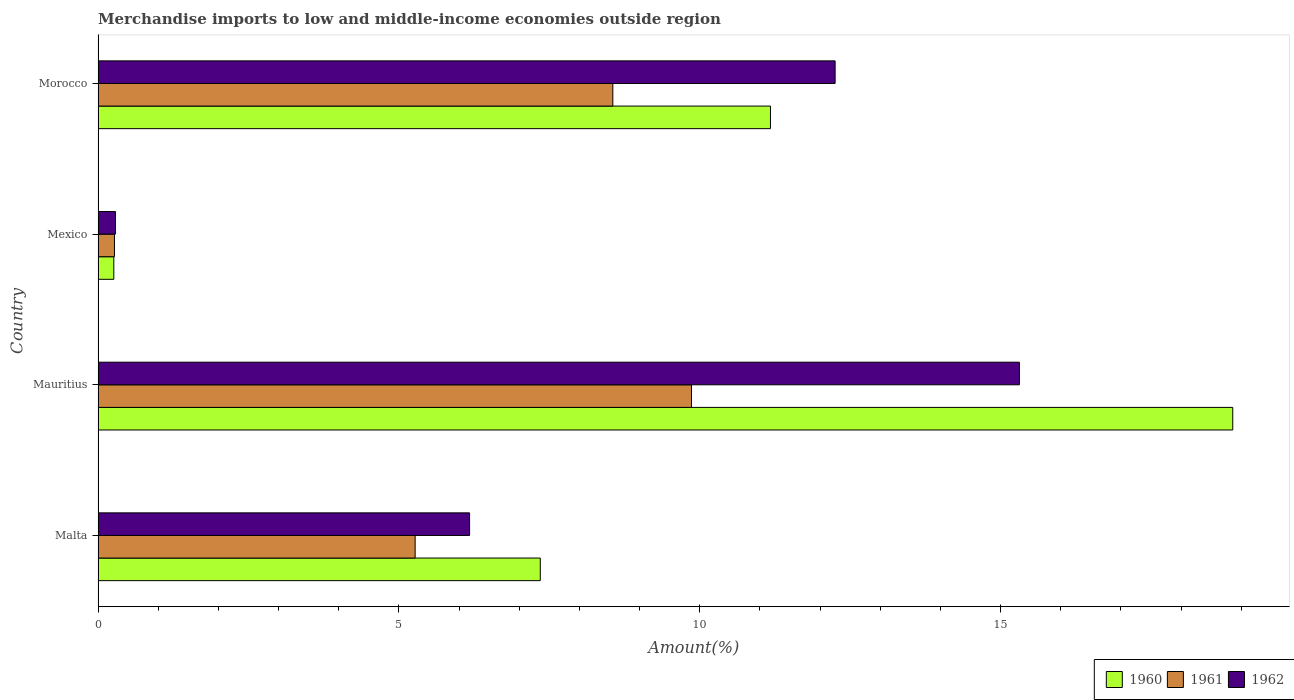How many different coloured bars are there?
Ensure brevity in your answer.  3. How many groups of bars are there?
Provide a short and direct response. 4. Are the number of bars per tick equal to the number of legend labels?
Your answer should be compact. Yes. How many bars are there on the 2nd tick from the bottom?
Your answer should be very brief. 3. In how many cases, is the number of bars for a given country not equal to the number of legend labels?
Your response must be concise. 0. What is the percentage of amount earned from merchandise imports in 1960 in Malta?
Your response must be concise. 7.35. Across all countries, what is the maximum percentage of amount earned from merchandise imports in 1960?
Provide a succinct answer. 18.86. Across all countries, what is the minimum percentage of amount earned from merchandise imports in 1962?
Give a very brief answer. 0.29. In which country was the percentage of amount earned from merchandise imports in 1960 maximum?
Ensure brevity in your answer.  Mauritius. In which country was the percentage of amount earned from merchandise imports in 1962 minimum?
Offer a very short reply. Mexico. What is the total percentage of amount earned from merchandise imports in 1960 in the graph?
Your response must be concise. 37.65. What is the difference between the percentage of amount earned from merchandise imports in 1961 in Mexico and that in Morocco?
Offer a terse response. -8.28. What is the difference between the percentage of amount earned from merchandise imports in 1961 in Morocco and the percentage of amount earned from merchandise imports in 1960 in Mexico?
Provide a short and direct response. 8.29. What is the average percentage of amount earned from merchandise imports in 1961 per country?
Provide a short and direct response. 5.99. What is the difference between the percentage of amount earned from merchandise imports in 1960 and percentage of amount earned from merchandise imports in 1962 in Malta?
Your answer should be compact. 1.17. What is the ratio of the percentage of amount earned from merchandise imports in 1960 in Mauritius to that in Morocco?
Provide a short and direct response. 1.69. Is the percentage of amount earned from merchandise imports in 1962 in Malta less than that in Mexico?
Offer a very short reply. No. What is the difference between the highest and the second highest percentage of amount earned from merchandise imports in 1961?
Keep it short and to the point. 1.31. What is the difference between the highest and the lowest percentage of amount earned from merchandise imports in 1962?
Offer a very short reply. 15.02. What does the 1st bar from the top in Mauritius represents?
Provide a short and direct response. 1962. How many countries are there in the graph?
Give a very brief answer. 4. What is the difference between two consecutive major ticks on the X-axis?
Ensure brevity in your answer.  5. Are the values on the major ticks of X-axis written in scientific E-notation?
Ensure brevity in your answer.  No. Does the graph contain grids?
Provide a short and direct response. No. Where does the legend appear in the graph?
Provide a short and direct response. Bottom right. How many legend labels are there?
Offer a terse response. 3. What is the title of the graph?
Give a very brief answer. Merchandise imports to low and middle-income economies outside region. What is the label or title of the X-axis?
Offer a terse response. Amount(%). What is the Amount(%) in 1960 in Malta?
Give a very brief answer. 7.35. What is the Amount(%) of 1961 in Malta?
Give a very brief answer. 5.27. What is the Amount(%) in 1962 in Malta?
Ensure brevity in your answer.  6.18. What is the Amount(%) of 1960 in Mauritius?
Your response must be concise. 18.86. What is the Amount(%) of 1961 in Mauritius?
Ensure brevity in your answer.  9.86. What is the Amount(%) of 1962 in Mauritius?
Make the answer very short. 15.31. What is the Amount(%) in 1960 in Mexico?
Keep it short and to the point. 0.26. What is the Amount(%) of 1961 in Mexico?
Ensure brevity in your answer.  0.27. What is the Amount(%) of 1962 in Mexico?
Ensure brevity in your answer.  0.29. What is the Amount(%) of 1960 in Morocco?
Provide a succinct answer. 11.18. What is the Amount(%) in 1961 in Morocco?
Give a very brief answer. 8.56. What is the Amount(%) of 1962 in Morocco?
Your answer should be very brief. 12.25. Across all countries, what is the maximum Amount(%) of 1960?
Keep it short and to the point. 18.86. Across all countries, what is the maximum Amount(%) in 1961?
Offer a very short reply. 9.86. Across all countries, what is the maximum Amount(%) of 1962?
Provide a succinct answer. 15.31. Across all countries, what is the minimum Amount(%) in 1960?
Give a very brief answer. 0.26. Across all countries, what is the minimum Amount(%) in 1961?
Make the answer very short. 0.27. Across all countries, what is the minimum Amount(%) of 1962?
Your answer should be compact. 0.29. What is the total Amount(%) of 1960 in the graph?
Offer a terse response. 37.65. What is the total Amount(%) in 1961 in the graph?
Ensure brevity in your answer.  23.96. What is the total Amount(%) in 1962 in the graph?
Your answer should be very brief. 34.03. What is the difference between the Amount(%) in 1960 in Malta and that in Mauritius?
Your answer should be very brief. -11.51. What is the difference between the Amount(%) of 1961 in Malta and that in Mauritius?
Offer a terse response. -4.59. What is the difference between the Amount(%) in 1962 in Malta and that in Mauritius?
Keep it short and to the point. -9.14. What is the difference between the Amount(%) of 1960 in Malta and that in Mexico?
Provide a short and direct response. 7.09. What is the difference between the Amount(%) of 1961 in Malta and that in Mexico?
Ensure brevity in your answer.  5. What is the difference between the Amount(%) of 1962 in Malta and that in Mexico?
Ensure brevity in your answer.  5.89. What is the difference between the Amount(%) of 1960 in Malta and that in Morocco?
Your response must be concise. -3.83. What is the difference between the Amount(%) in 1961 in Malta and that in Morocco?
Your answer should be compact. -3.29. What is the difference between the Amount(%) in 1962 in Malta and that in Morocco?
Provide a succinct answer. -6.08. What is the difference between the Amount(%) in 1960 in Mauritius and that in Mexico?
Provide a succinct answer. 18.6. What is the difference between the Amount(%) of 1961 in Mauritius and that in Mexico?
Keep it short and to the point. 9.59. What is the difference between the Amount(%) in 1962 in Mauritius and that in Mexico?
Your answer should be very brief. 15.02. What is the difference between the Amount(%) of 1960 in Mauritius and that in Morocco?
Your answer should be compact. 7.68. What is the difference between the Amount(%) in 1961 in Mauritius and that in Morocco?
Ensure brevity in your answer.  1.31. What is the difference between the Amount(%) in 1962 in Mauritius and that in Morocco?
Make the answer very short. 3.06. What is the difference between the Amount(%) of 1960 in Mexico and that in Morocco?
Make the answer very short. -10.91. What is the difference between the Amount(%) in 1961 in Mexico and that in Morocco?
Offer a very short reply. -8.28. What is the difference between the Amount(%) in 1962 in Mexico and that in Morocco?
Provide a succinct answer. -11.96. What is the difference between the Amount(%) in 1960 in Malta and the Amount(%) in 1961 in Mauritius?
Provide a short and direct response. -2.51. What is the difference between the Amount(%) of 1960 in Malta and the Amount(%) of 1962 in Mauritius?
Offer a terse response. -7.96. What is the difference between the Amount(%) of 1961 in Malta and the Amount(%) of 1962 in Mauritius?
Your answer should be compact. -10.04. What is the difference between the Amount(%) of 1960 in Malta and the Amount(%) of 1961 in Mexico?
Keep it short and to the point. 7.08. What is the difference between the Amount(%) in 1960 in Malta and the Amount(%) in 1962 in Mexico?
Keep it short and to the point. 7.06. What is the difference between the Amount(%) of 1961 in Malta and the Amount(%) of 1962 in Mexico?
Your answer should be very brief. 4.98. What is the difference between the Amount(%) of 1960 in Malta and the Amount(%) of 1961 in Morocco?
Your response must be concise. -1.21. What is the difference between the Amount(%) of 1960 in Malta and the Amount(%) of 1962 in Morocco?
Your response must be concise. -4.9. What is the difference between the Amount(%) in 1961 in Malta and the Amount(%) in 1962 in Morocco?
Keep it short and to the point. -6.98. What is the difference between the Amount(%) of 1960 in Mauritius and the Amount(%) of 1961 in Mexico?
Keep it short and to the point. 18.59. What is the difference between the Amount(%) in 1960 in Mauritius and the Amount(%) in 1962 in Mexico?
Your answer should be compact. 18.57. What is the difference between the Amount(%) of 1961 in Mauritius and the Amount(%) of 1962 in Mexico?
Ensure brevity in your answer.  9.57. What is the difference between the Amount(%) of 1960 in Mauritius and the Amount(%) of 1961 in Morocco?
Provide a succinct answer. 10.3. What is the difference between the Amount(%) of 1960 in Mauritius and the Amount(%) of 1962 in Morocco?
Make the answer very short. 6.61. What is the difference between the Amount(%) of 1961 in Mauritius and the Amount(%) of 1962 in Morocco?
Give a very brief answer. -2.39. What is the difference between the Amount(%) of 1960 in Mexico and the Amount(%) of 1961 in Morocco?
Your response must be concise. -8.29. What is the difference between the Amount(%) of 1960 in Mexico and the Amount(%) of 1962 in Morocco?
Offer a very short reply. -11.99. What is the difference between the Amount(%) in 1961 in Mexico and the Amount(%) in 1962 in Morocco?
Provide a succinct answer. -11.98. What is the average Amount(%) of 1960 per country?
Your answer should be very brief. 9.41. What is the average Amount(%) in 1961 per country?
Your response must be concise. 5.99. What is the average Amount(%) of 1962 per country?
Offer a very short reply. 8.51. What is the difference between the Amount(%) in 1960 and Amount(%) in 1961 in Malta?
Offer a terse response. 2.08. What is the difference between the Amount(%) of 1960 and Amount(%) of 1962 in Malta?
Provide a short and direct response. 1.17. What is the difference between the Amount(%) in 1961 and Amount(%) in 1962 in Malta?
Offer a terse response. -0.9. What is the difference between the Amount(%) in 1960 and Amount(%) in 1961 in Mauritius?
Your answer should be compact. 9. What is the difference between the Amount(%) in 1960 and Amount(%) in 1962 in Mauritius?
Your response must be concise. 3.55. What is the difference between the Amount(%) of 1961 and Amount(%) of 1962 in Mauritius?
Keep it short and to the point. -5.45. What is the difference between the Amount(%) in 1960 and Amount(%) in 1961 in Mexico?
Provide a short and direct response. -0.01. What is the difference between the Amount(%) in 1960 and Amount(%) in 1962 in Mexico?
Your response must be concise. -0.03. What is the difference between the Amount(%) of 1961 and Amount(%) of 1962 in Mexico?
Offer a very short reply. -0.02. What is the difference between the Amount(%) in 1960 and Amount(%) in 1961 in Morocco?
Give a very brief answer. 2.62. What is the difference between the Amount(%) in 1960 and Amount(%) in 1962 in Morocco?
Make the answer very short. -1.07. What is the difference between the Amount(%) of 1961 and Amount(%) of 1962 in Morocco?
Your answer should be very brief. -3.69. What is the ratio of the Amount(%) in 1960 in Malta to that in Mauritius?
Ensure brevity in your answer.  0.39. What is the ratio of the Amount(%) in 1961 in Malta to that in Mauritius?
Make the answer very short. 0.53. What is the ratio of the Amount(%) in 1962 in Malta to that in Mauritius?
Offer a terse response. 0.4. What is the ratio of the Amount(%) in 1960 in Malta to that in Mexico?
Your answer should be compact. 28.05. What is the ratio of the Amount(%) in 1961 in Malta to that in Mexico?
Offer a very short reply. 19.32. What is the ratio of the Amount(%) in 1962 in Malta to that in Mexico?
Offer a very short reply. 21.31. What is the ratio of the Amount(%) of 1960 in Malta to that in Morocco?
Ensure brevity in your answer.  0.66. What is the ratio of the Amount(%) of 1961 in Malta to that in Morocco?
Your answer should be very brief. 0.62. What is the ratio of the Amount(%) in 1962 in Malta to that in Morocco?
Provide a succinct answer. 0.5. What is the ratio of the Amount(%) in 1960 in Mauritius to that in Mexico?
Ensure brevity in your answer.  71.98. What is the ratio of the Amount(%) of 1961 in Mauritius to that in Mexico?
Make the answer very short. 36.15. What is the ratio of the Amount(%) of 1962 in Mauritius to that in Mexico?
Offer a very short reply. 52.86. What is the ratio of the Amount(%) in 1960 in Mauritius to that in Morocco?
Offer a terse response. 1.69. What is the ratio of the Amount(%) in 1961 in Mauritius to that in Morocco?
Your response must be concise. 1.15. What is the ratio of the Amount(%) of 1962 in Mauritius to that in Morocco?
Provide a succinct answer. 1.25. What is the ratio of the Amount(%) in 1960 in Mexico to that in Morocco?
Make the answer very short. 0.02. What is the ratio of the Amount(%) of 1961 in Mexico to that in Morocco?
Your answer should be compact. 0.03. What is the ratio of the Amount(%) of 1962 in Mexico to that in Morocco?
Give a very brief answer. 0.02. What is the difference between the highest and the second highest Amount(%) of 1960?
Your response must be concise. 7.68. What is the difference between the highest and the second highest Amount(%) of 1961?
Offer a terse response. 1.31. What is the difference between the highest and the second highest Amount(%) in 1962?
Your answer should be compact. 3.06. What is the difference between the highest and the lowest Amount(%) in 1960?
Ensure brevity in your answer.  18.6. What is the difference between the highest and the lowest Amount(%) in 1961?
Your response must be concise. 9.59. What is the difference between the highest and the lowest Amount(%) of 1962?
Your answer should be compact. 15.02. 